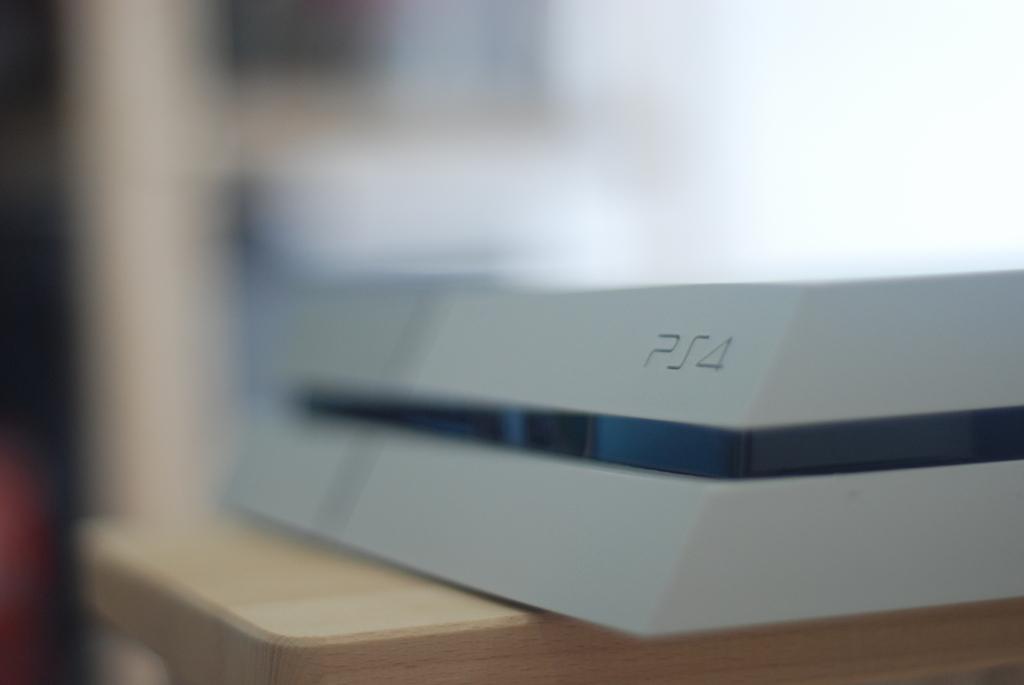Is that a ps4?
Provide a short and direct response. Yes. Does that box say ps4 on the right?
Offer a terse response. Yes. 